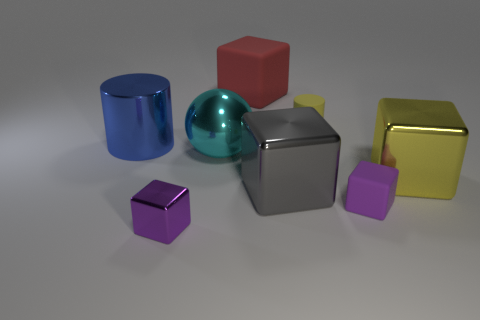How many purple cubes must be subtracted to get 1 purple cubes? 1 Subtract all small purple matte cubes. How many cubes are left? 4 Subtract all gray blocks. How many blocks are left? 4 Subtract all cubes. How many objects are left? 3 Subtract 1 cylinders. How many cylinders are left? 1 Add 1 large purple metal cylinders. How many objects exist? 9 Add 6 large balls. How many large balls are left? 7 Add 3 small blue shiny cylinders. How many small blue shiny cylinders exist? 3 Subtract 0 red cylinders. How many objects are left? 8 Subtract all purple blocks. Subtract all green spheres. How many blocks are left? 3 